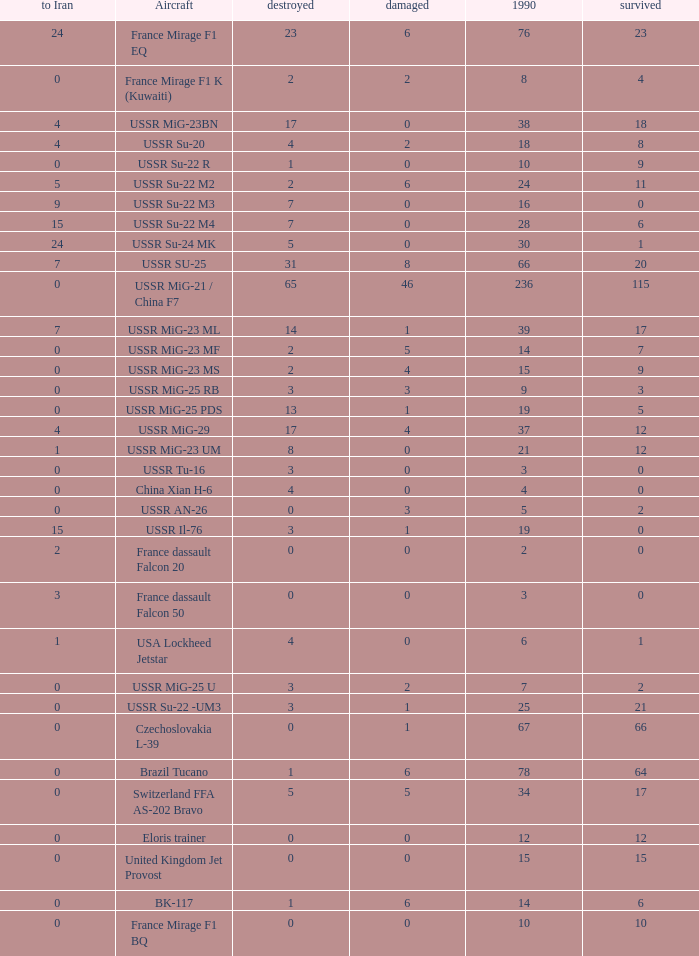If the aircraft was  ussr mig-25 rb how many were destroyed? 3.0. 